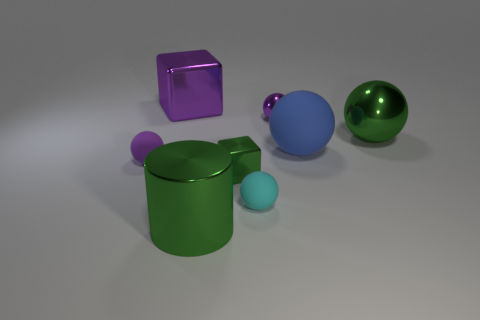Is there a large block of the same color as the small metal sphere?
Your answer should be compact. Yes. Are there any other things that are the same size as the cyan rubber ball?
Offer a terse response. Yes. How many small objects have the same color as the big rubber sphere?
Offer a terse response. 0. There is a small metal sphere; is its color the same as the large thing in front of the big rubber sphere?
Offer a very short reply. No. How many things are cylinders or green metallic things that are behind the tiny cyan thing?
Keep it short and to the point. 3. What is the size of the metallic object to the right of the small purple ball on the right side of the big purple object?
Offer a terse response. Large. Is the number of tiny cyan balls that are behind the big purple thing the same as the number of large blocks that are behind the big blue ball?
Ensure brevity in your answer.  No. There is a small ball right of the cyan sphere; are there any purple objects that are left of it?
Your answer should be very brief. Yes. There is a purple thing that is made of the same material as the blue sphere; what shape is it?
Your response must be concise. Sphere. Is there anything else that has the same color as the large metallic cylinder?
Make the answer very short. Yes. 